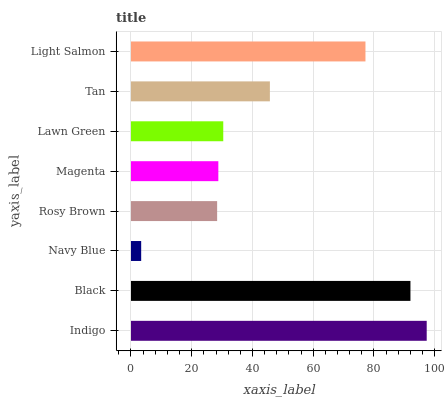Is Navy Blue the minimum?
Answer yes or no. Yes. Is Indigo the maximum?
Answer yes or no. Yes. Is Black the minimum?
Answer yes or no. No. Is Black the maximum?
Answer yes or no. No. Is Indigo greater than Black?
Answer yes or no. Yes. Is Black less than Indigo?
Answer yes or no. Yes. Is Black greater than Indigo?
Answer yes or no. No. Is Indigo less than Black?
Answer yes or no. No. Is Tan the high median?
Answer yes or no. Yes. Is Lawn Green the low median?
Answer yes or no. Yes. Is Light Salmon the high median?
Answer yes or no. No. Is Navy Blue the low median?
Answer yes or no. No. 